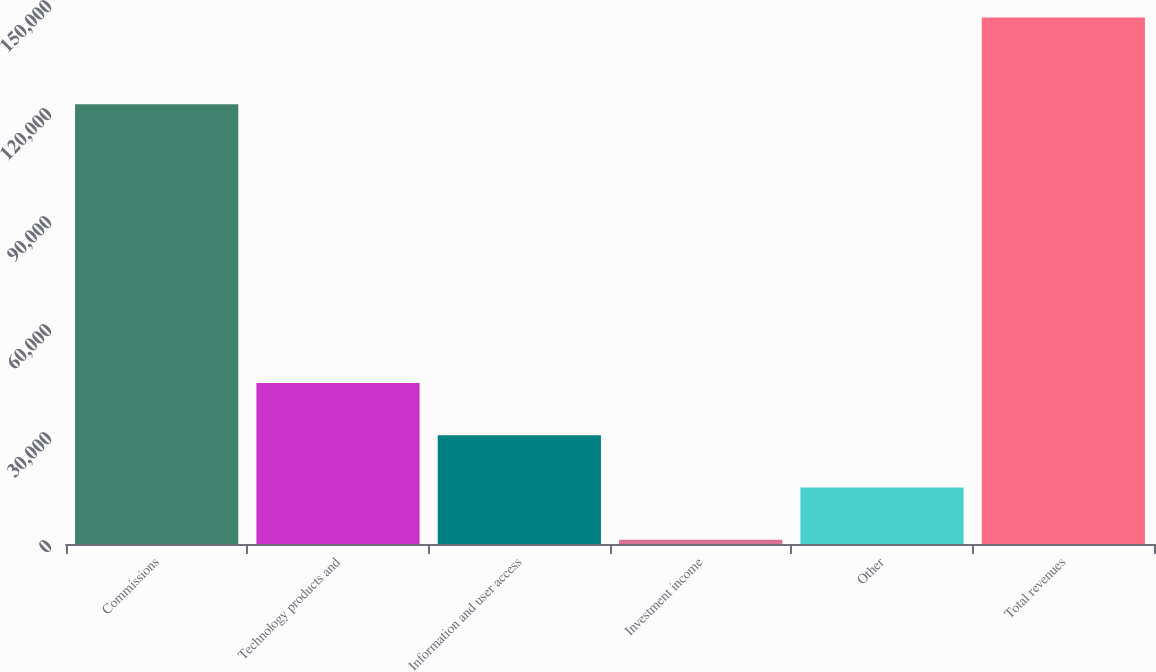Convert chart. <chart><loc_0><loc_0><loc_500><loc_500><bar_chart><fcel>Commissions<fcel>Technology products and<fcel>Information and user access<fcel>Investment income<fcel>Other<fcel>Total revenues<nl><fcel>122180<fcel>44702.8<fcel>30199.2<fcel>1192<fcel>15695.6<fcel>146228<nl></chart> 